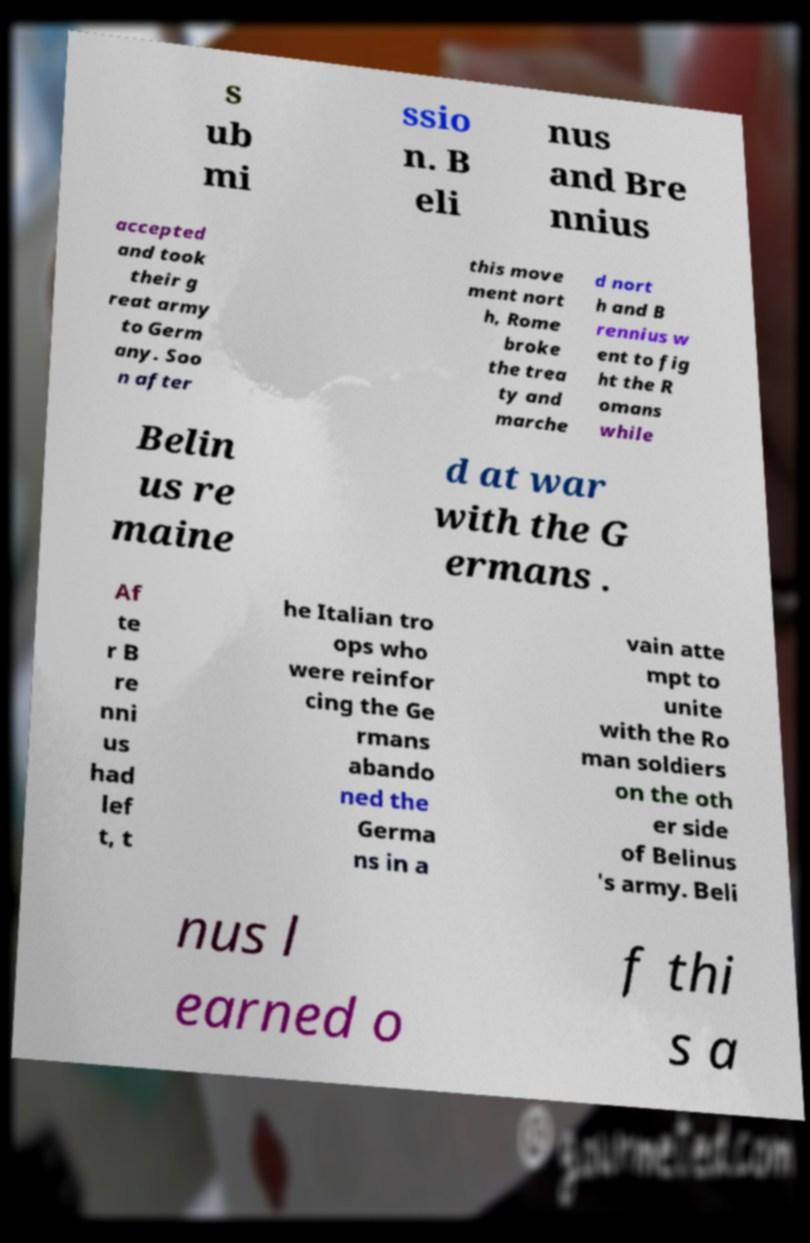Please read and relay the text visible in this image. What does it say? s ub mi ssio n. B eli nus and Bre nnius accepted and took their g reat army to Germ any. Soo n after this move ment nort h, Rome broke the trea ty and marche d nort h and B rennius w ent to fig ht the R omans while Belin us re maine d at war with the G ermans . Af te r B re nni us had lef t, t he Italian tro ops who were reinfor cing the Ge rmans abando ned the Germa ns in a vain atte mpt to unite with the Ro man soldiers on the oth er side of Belinus 's army. Beli nus l earned o f thi s a 